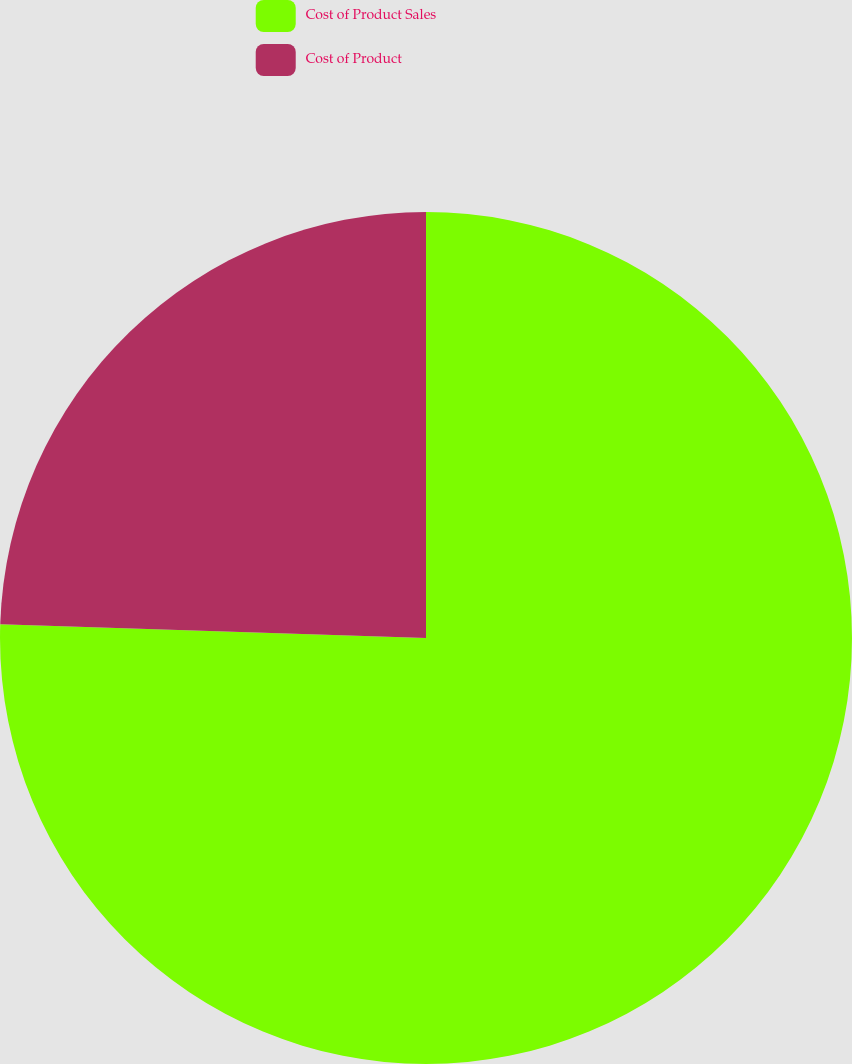Convert chart to OTSL. <chart><loc_0><loc_0><loc_500><loc_500><pie_chart><fcel>Cost of Product Sales<fcel>Cost of Product<nl><fcel>75.51%<fcel>24.49%<nl></chart> 